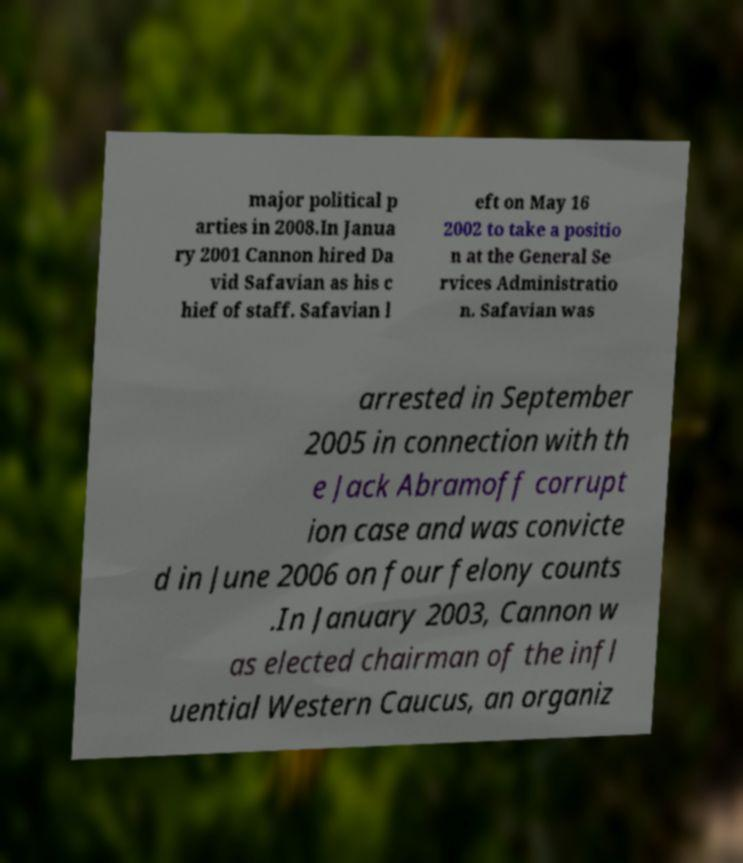Can you accurately transcribe the text from the provided image for me? major political p arties in 2008.In Janua ry 2001 Cannon hired Da vid Safavian as his c hief of staff. Safavian l eft on May 16 2002 to take a positio n at the General Se rvices Administratio n. Safavian was arrested in September 2005 in connection with th e Jack Abramoff corrupt ion case and was convicte d in June 2006 on four felony counts .In January 2003, Cannon w as elected chairman of the infl uential Western Caucus, an organiz 